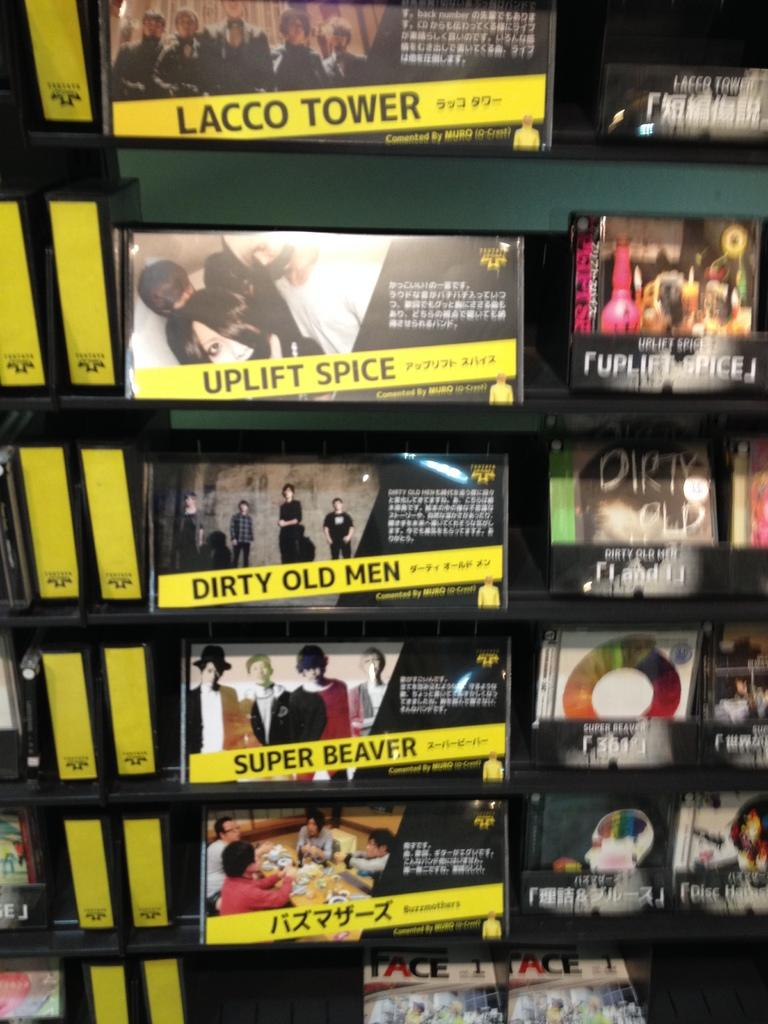<image>
Give a short and clear explanation of the subsequent image. Super Beaver is for sale with Uplift Spice and other CDs. 